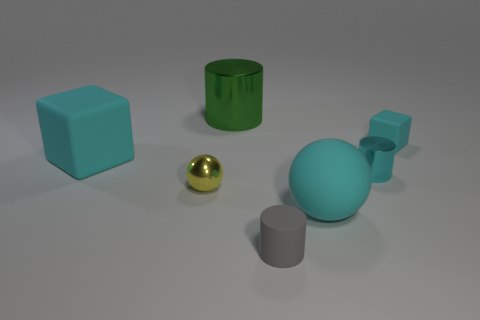What number of things are yellow shiny things that are in front of the small cyan cylinder or small things that are to the right of the tiny gray cylinder?
Offer a very short reply. 3. What number of other objects are the same size as the green object?
Offer a terse response. 2. There is a cyan rubber thing that is left of the large object that is behind the tiny cyan block; what is its shape?
Provide a short and direct response. Cube. Does the big thing to the left of the large green metal object have the same color as the metallic cylinder left of the cyan metallic cylinder?
Provide a short and direct response. No. Are there any other things that are the same color as the small rubber cylinder?
Give a very brief answer. No. What color is the matte cylinder?
Keep it short and to the point. Gray. Are there any small cyan metal things?
Provide a succinct answer. Yes. There is a green metal object; are there any gray cylinders left of it?
Give a very brief answer. No. There is another tiny thing that is the same shape as the small gray object; what material is it?
Ensure brevity in your answer.  Metal. What number of other things are there of the same shape as the tiny cyan metallic thing?
Provide a short and direct response. 2. 